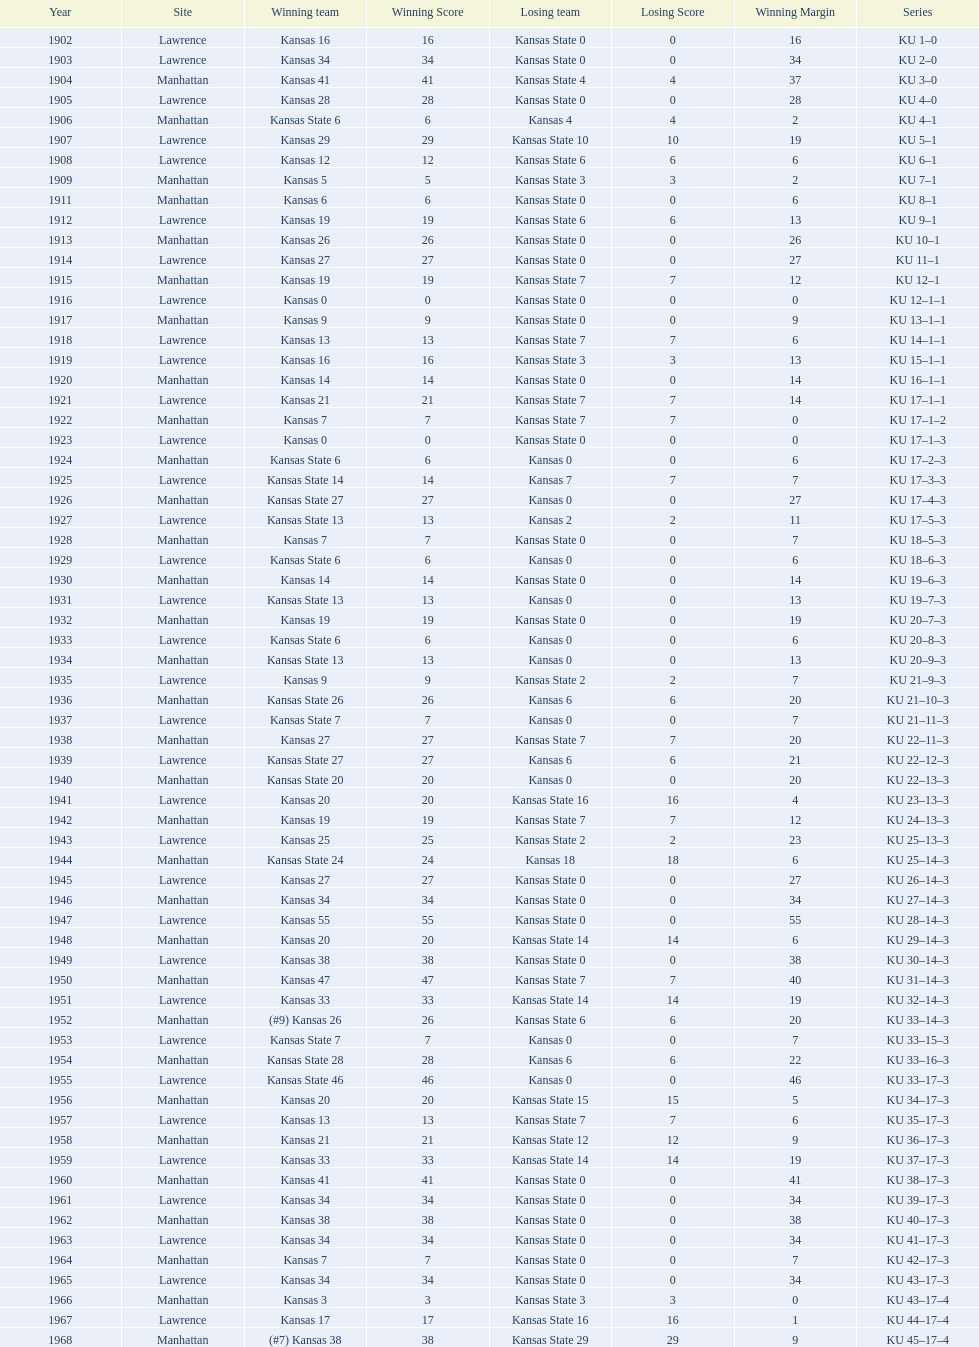Before 1950 what was the most points kansas scored? 55. 